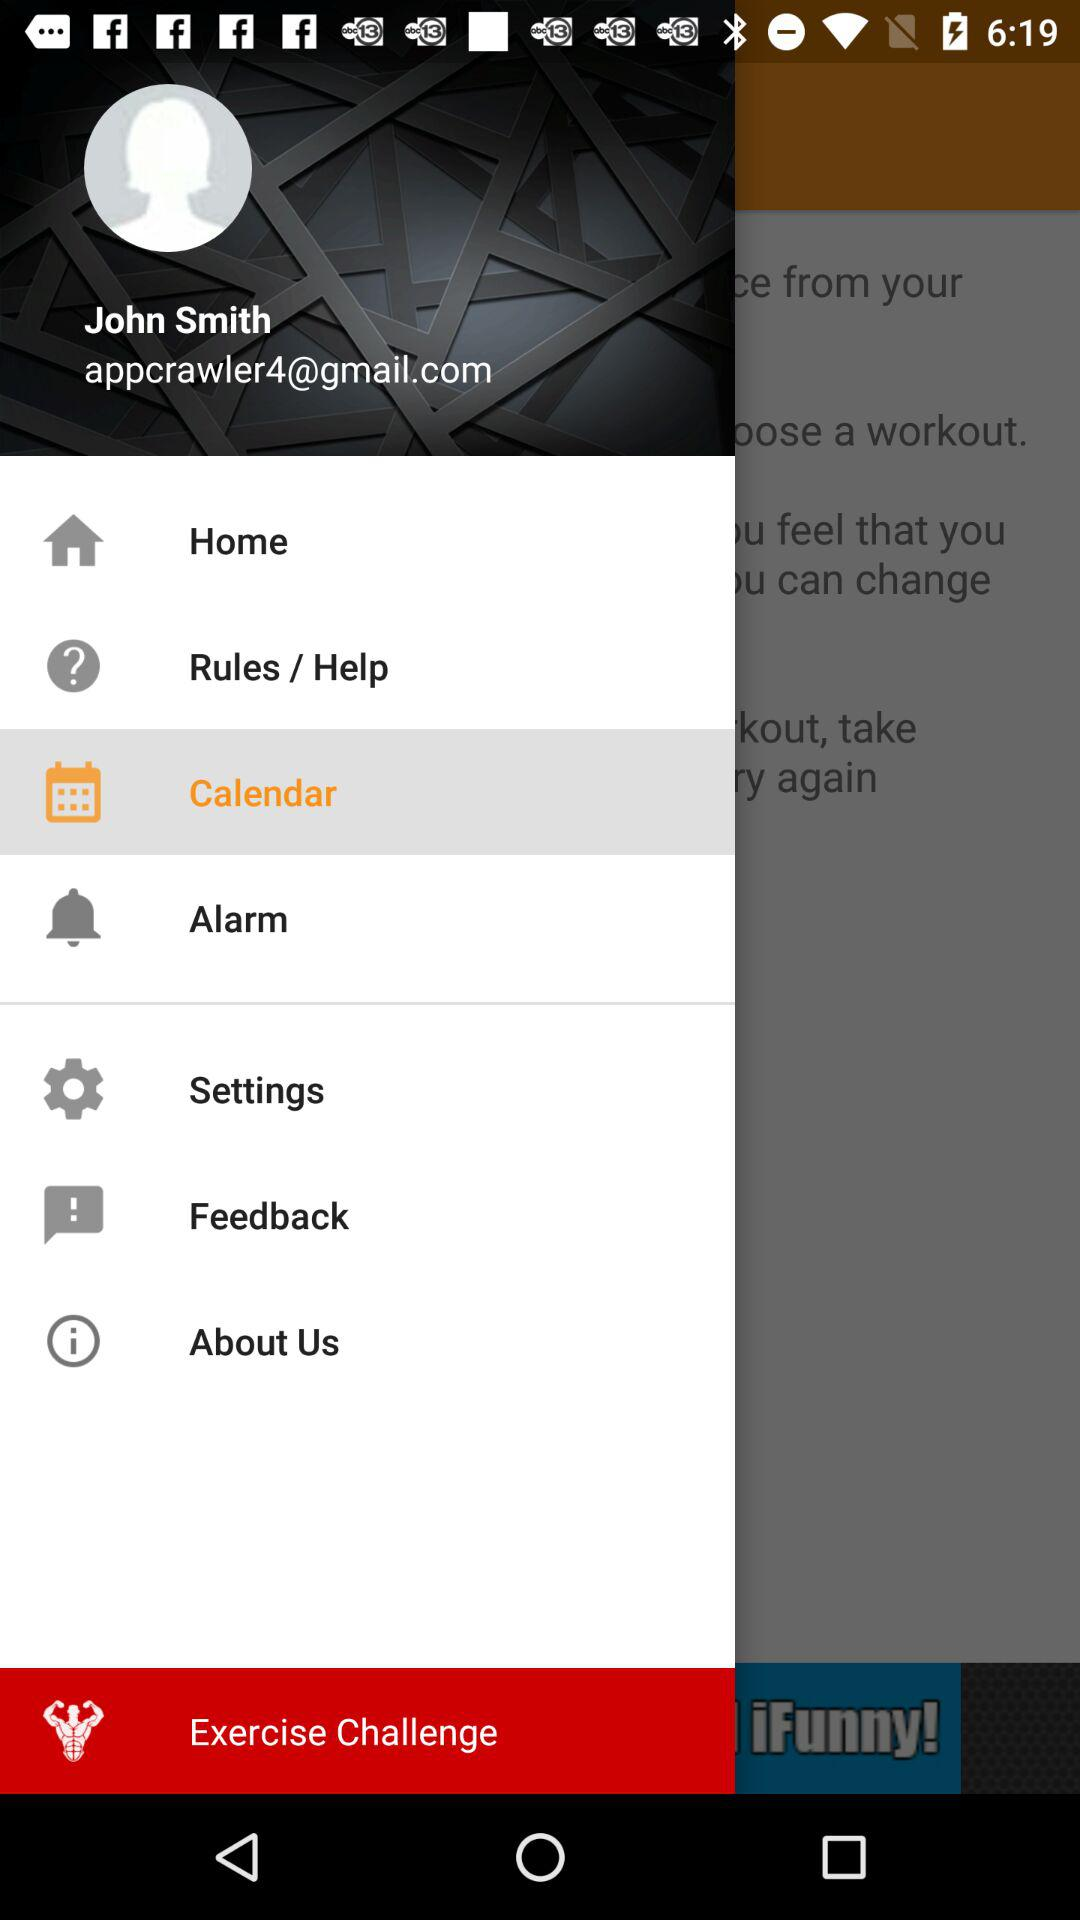What email address is shown on the screen? The email address shown on the screen is appcrawler4@gmail.com. 